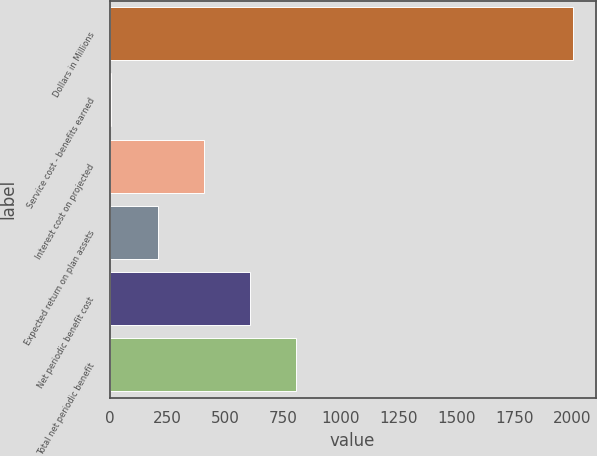Convert chart. <chart><loc_0><loc_0><loc_500><loc_500><bar_chart><fcel>Dollars in Millions<fcel>Service cost - benefits earned<fcel>Interest cost on projected<fcel>Expected return on plan assets<fcel>Net periodic benefit cost<fcel>Total net periodic benefit<nl><fcel>2003<fcel>8<fcel>407<fcel>207.5<fcel>606.5<fcel>806<nl></chart> 